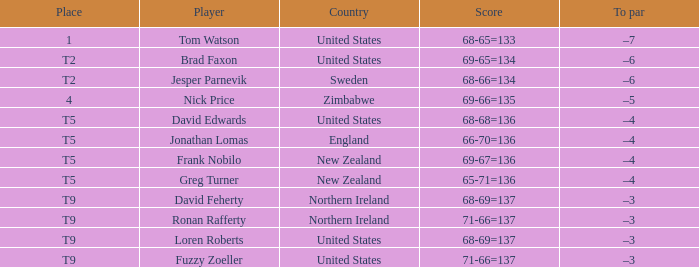Could you help me parse every detail presented in this table? {'header': ['Place', 'Player', 'Country', 'Score', 'To par'], 'rows': [['1', 'Tom Watson', 'United States', '68-65=133', '–7'], ['T2', 'Brad Faxon', 'United States', '69-65=134', '–6'], ['T2', 'Jesper Parnevik', 'Sweden', '68-66=134', '–6'], ['4', 'Nick Price', 'Zimbabwe', '69-66=135', '–5'], ['T5', 'David Edwards', 'United States', '68-68=136', '–4'], ['T5', 'Jonathan Lomas', 'England', '66-70=136', '–4'], ['T5', 'Frank Nobilo', 'New Zealand', '69-67=136', '–4'], ['T5', 'Greg Turner', 'New Zealand', '65-71=136', '–4'], ['T9', 'David Feherty', 'Northern Ireland', '68-69=137', '–3'], ['T9', 'Ronan Rafferty', 'Northern Ireland', '71-66=137', '–3'], ['T9', 'Loren Roberts', 'United States', '68-69=137', '–3'], ['T9', 'Fuzzy Zoeller', 'United States', '71-66=137', '–3']]} The golfer in place 1 if from what country? United States. 